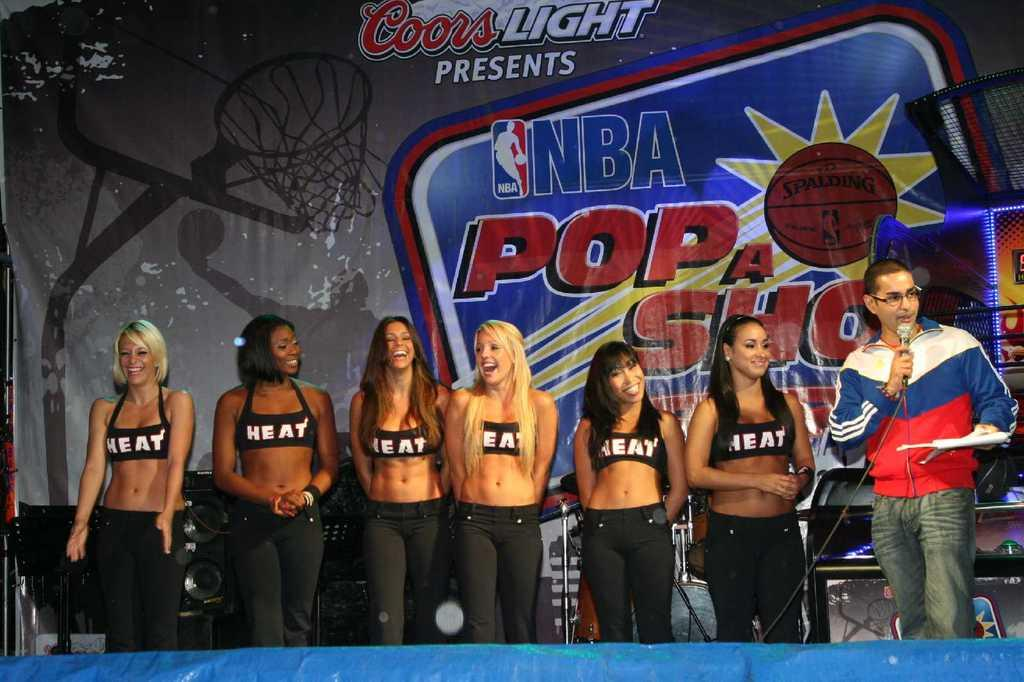<image>
Give a short and clear explanation of the subsequent image. A man and several women are standing in front of a sign that says NBA Pop a Shot. 